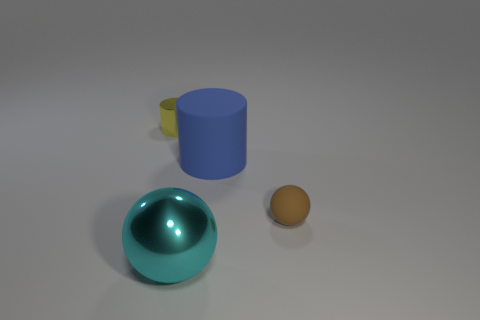There is a object that is behind the tiny brown thing and on the left side of the big blue object; what is it made of?
Your answer should be compact. Metal. What number of tiny objects are yellow rubber cubes or yellow things?
Offer a very short reply. 1. How big is the blue matte thing?
Provide a short and direct response. Large. What is the shape of the cyan thing?
Give a very brief answer. Sphere. Is there anything else that is the same shape as the yellow object?
Offer a very short reply. Yes. Is the number of rubber balls that are on the left side of the large matte thing less than the number of small yellow cubes?
Your response must be concise. No. There is a object that is to the left of the large ball; is it the same color as the metal sphere?
Offer a terse response. No. How many matte things are yellow cylinders or small green cylinders?
Provide a short and direct response. 0. Is there any other thing that has the same size as the cyan sphere?
Make the answer very short. Yes. There is a thing that is made of the same material as the big sphere; what color is it?
Ensure brevity in your answer.  Yellow. 